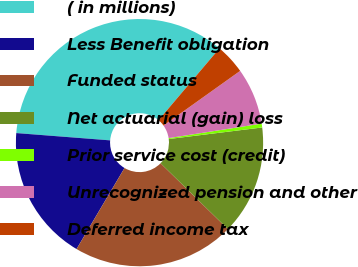Convert chart. <chart><loc_0><loc_0><loc_500><loc_500><pie_chart><fcel>( in millions)<fcel>Less Benefit obligation<fcel>Funded status<fcel>Net actuarial (gain) loss<fcel>Prior service cost (credit)<fcel>Unrecognized pension and other<fcel>Deferred income tax<nl><fcel>34.96%<fcel>17.73%<fcel>21.18%<fcel>14.29%<fcel>0.5%<fcel>7.4%<fcel>3.95%<nl></chart> 